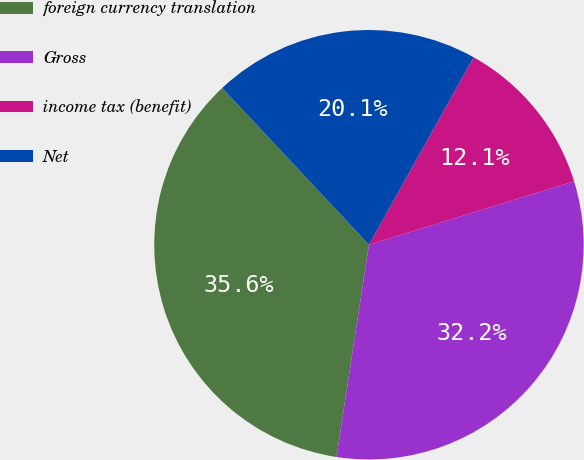Convert chart to OTSL. <chart><loc_0><loc_0><loc_500><loc_500><pie_chart><fcel>foreign currency translation<fcel>Gross<fcel>income tax (benefit)<fcel>Net<nl><fcel>35.61%<fcel>32.19%<fcel>12.12%<fcel>20.08%<nl></chart> 